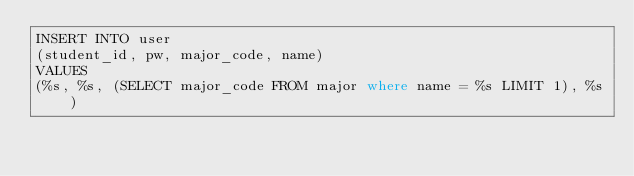Convert code to text. <code><loc_0><loc_0><loc_500><loc_500><_SQL_>INSERT INTO user 
(student_id, pw, major_code, name)
VALUES 
(%s, %s, (SELECT major_code FROM major where name = %s LIMIT 1), %s)</code> 